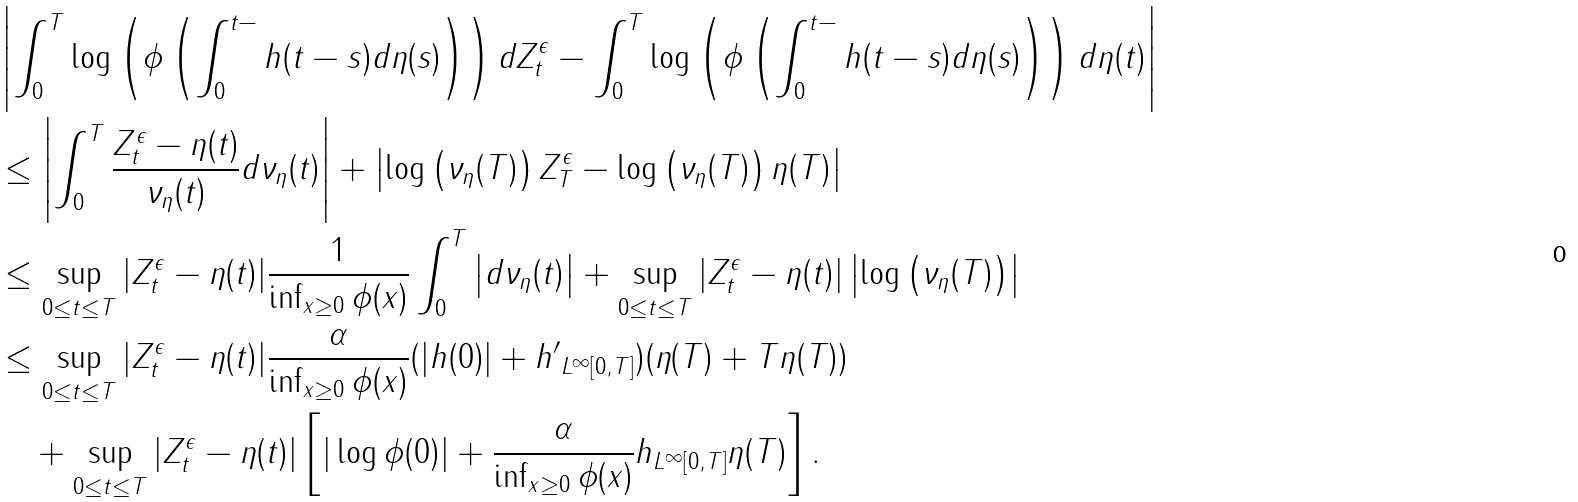<formula> <loc_0><loc_0><loc_500><loc_500>& \left | \int _ { 0 } ^ { T } \log \left ( \phi \left ( \int _ { 0 } ^ { t - } h ( t - s ) d \eta ( s ) \right ) \right ) d Z _ { t } ^ { \epsilon } - \int _ { 0 } ^ { T } \log \left ( \phi \left ( \int _ { 0 } ^ { t - } h ( t - s ) d \eta ( s ) \right ) \right ) d \eta ( t ) \right | \\ & \leq \left | \int _ { 0 } ^ { T } \frac { Z _ { t } ^ { \epsilon } - \eta ( t ) } { \nu _ { \eta } ( t ) } d \nu _ { \eta } ( t ) \right | + \left | \log \left ( \nu _ { \eta } ( T ) \right ) Z _ { T } ^ { \epsilon } - \log \left ( \nu _ { \eta } ( T ) \right ) \eta ( T ) \right | \\ & \leq \sup _ { 0 \leq t \leq T } | Z _ { t } ^ { \epsilon } - \eta ( t ) | \frac { 1 } { \inf _ { x \geq 0 } \phi ( x ) } \int _ { 0 } ^ { T } \left | d \nu _ { \eta } ( t ) \right | + \sup _ { 0 \leq t \leq T } | Z _ { t } ^ { \epsilon } - \eta ( t ) | \left | \log \left ( \nu _ { \eta } ( T ) \right ) \right | \\ & \leq \sup _ { 0 \leq t \leq T } | Z _ { t } ^ { \epsilon } - \eta ( t ) | \frac { \alpha } { \inf _ { x \geq 0 } \phi ( x ) } ( | h ( 0 ) | + \| h ^ { \prime } \| _ { L ^ { \infty } [ 0 , T ] } ) ( \eta ( T ) + T \eta ( T ) ) \\ & \quad + \sup _ { 0 \leq t \leq T } | Z _ { t } ^ { \epsilon } - \eta ( t ) | \left [ | \log \phi ( 0 ) | + \frac { \alpha } { \inf _ { x \geq 0 } \phi ( x ) } \| h \| _ { L ^ { \infty } [ 0 , T ] } \eta ( T ) \right ] .</formula> 